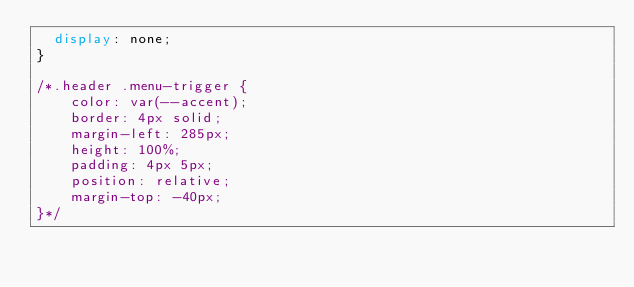<code> <loc_0><loc_0><loc_500><loc_500><_CSS_>  display: none;
}

/*.header .menu-trigger {
    color: var(--accent);
    border: 4px solid;
    margin-left: 285px;
    height: 100%;
    padding: 4px 5px;
    position: relative;
    margin-top: -40px;
}*/
</code> 